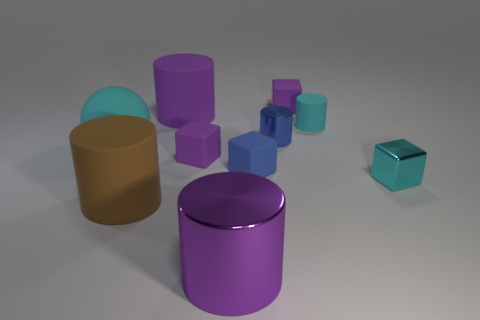There is a blue cylinder that is the same size as the blue matte block; what is it made of?
Keep it short and to the point. Metal. What is the shape of the blue rubber object?
Your answer should be compact. Cube. What number of brown things are big balls or metal cubes?
Your answer should be compact. 0. What size is the blue thing that is the same material as the big ball?
Your answer should be compact. Small. Does the large thing that is behind the ball have the same material as the purple thing that is in front of the cyan metallic object?
Keep it short and to the point. No. What number of cylinders are big cyan objects or tiny purple rubber objects?
Your response must be concise. 0. What number of balls are in front of the large object right of the purple cylinder that is behind the small cyan metal cube?
Ensure brevity in your answer.  0. There is a blue thing that is the same shape as the large brown rubber object; what is it made of?
Offer a very short reply. Metal. What is the color of the small metallic object on the right side of the tiny blue cylinder?
Ensure brevity in your answer.  Cyan. Does the big ball have the same material as the purple cylinder in front of the tiny cyan block?
Ensure brevity in your answer.  No. 